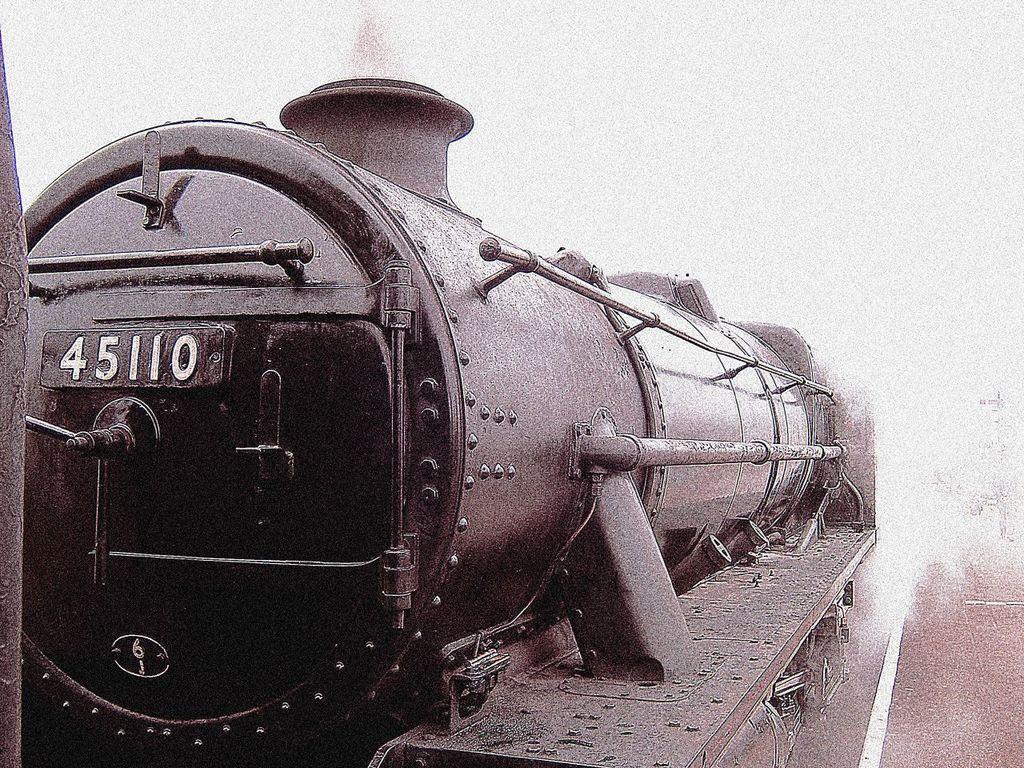Could you give a brief overview of what you see in this image? In this image we can see a black and white image. In this image we can see a locomotive. In the background of the image there is a white background. 